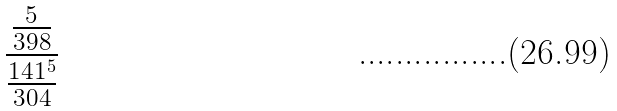Convert formula to latex. <formula><loc_0><loc_0><loc_500><loc_500>\frac { \frac { 5 } { 3 9 8 } } { \frac { 1 4 1 ^ { 5 } } { 3 0 4 } }</formula> 